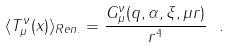Convert formula to latex. <formula><loc_0><loc_0><loc_500><loc_500>\langle T ^ { \nu } _ { \mu } ( x ) \rangle _ { R e n . } = \frac { G ^ { \nu } _ { \mu } ( q , \alpha , \xi , \mu r ) } { r ^ { 4 } } \ .</formula> 